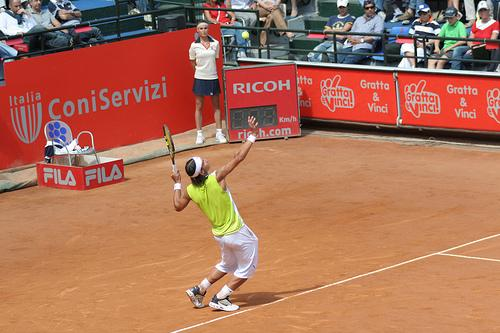Which hand caused the ball to go aloft here? right 